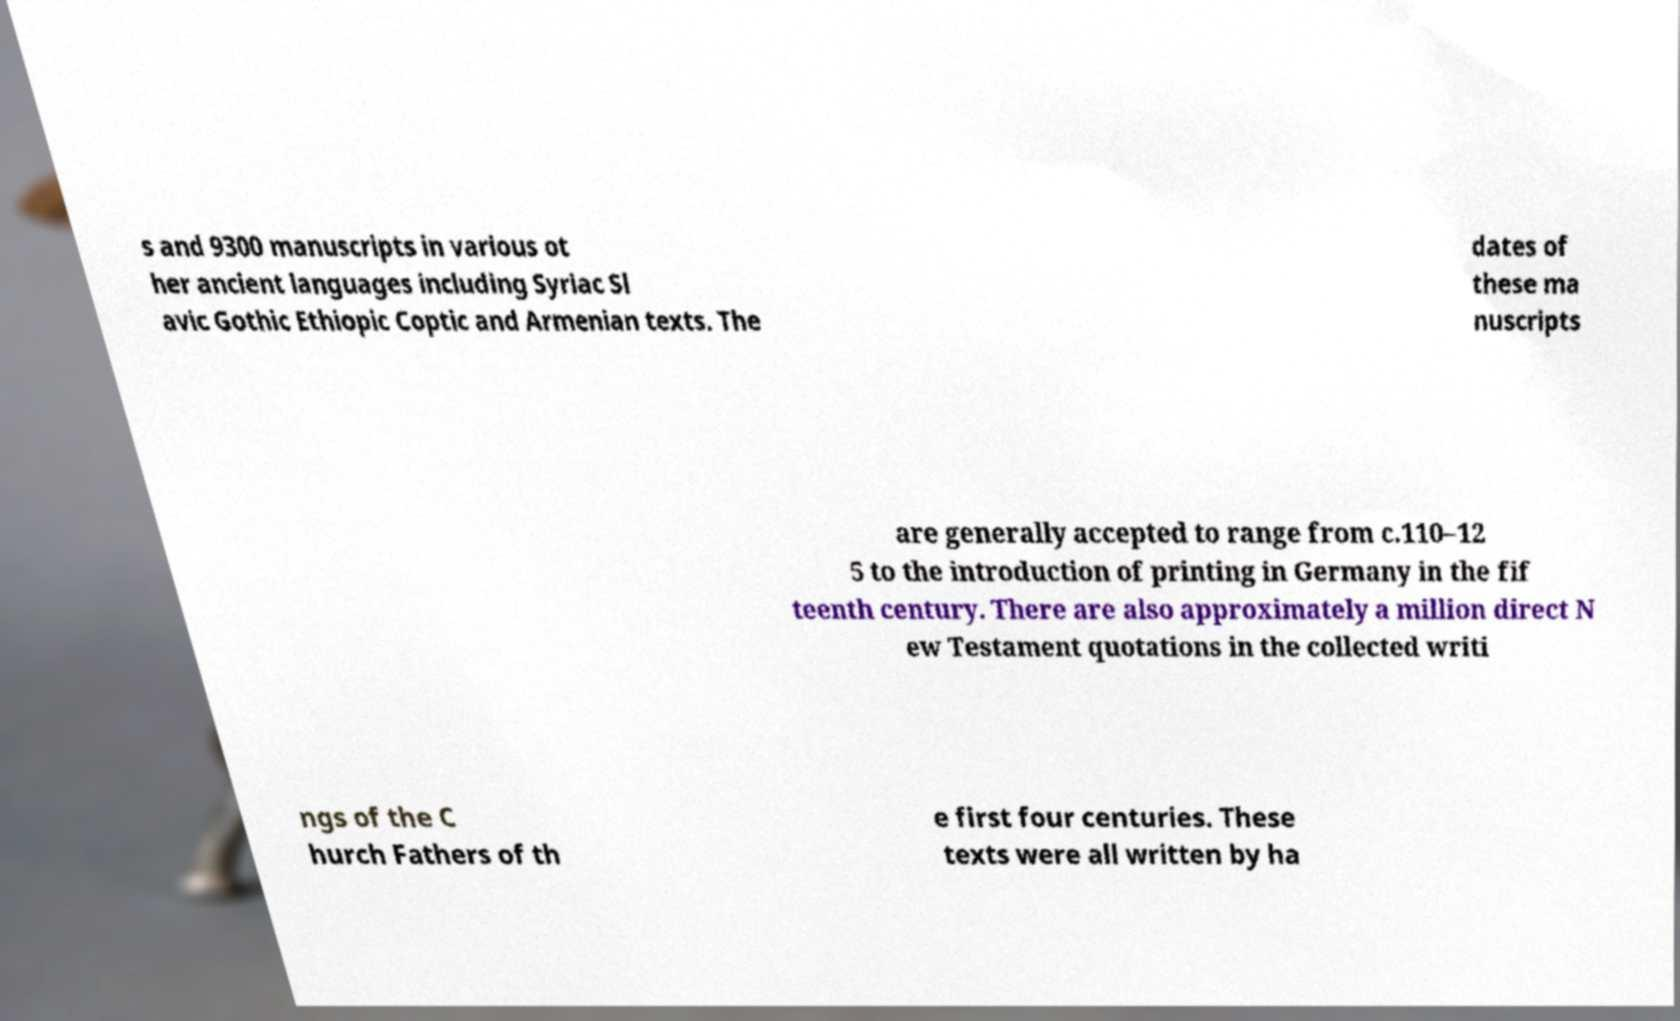Please read and relay the text visible in this image. What does it say? s and 9300 manuscripts in various ot her ancient languages including Syriac Sl avic Gothic Ethiopic Coptic and Armenian texts. The dates of these ma nuscripts are generally accepted to range from c.110–12 5 to the introduction of printing in Germany in the fif teenth century. There are also approximately a million direct N ew Testament quotations in the collected writi ngs of the C hurch Fathers of th e first four centuries. These texts were all written by ha 